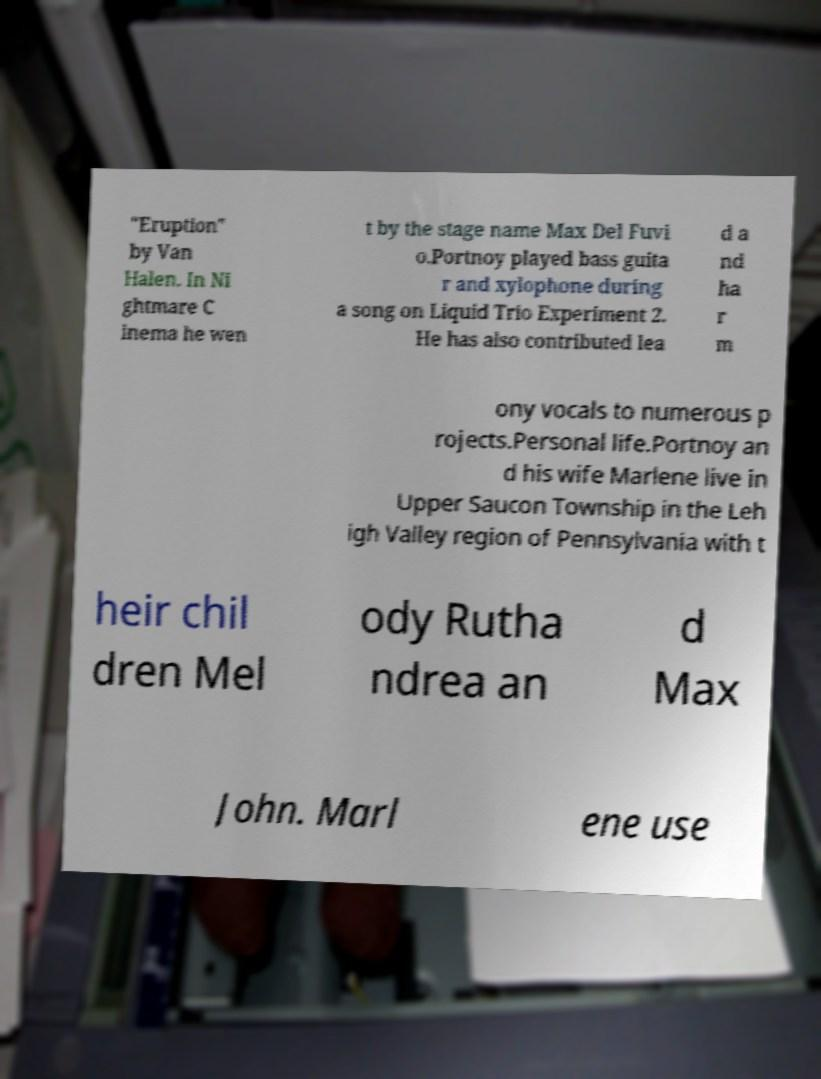For documentation purposes, I need the text within this image transcribed. Could you provide that? "Eruption" by Van Halen. In Ni ghtmare C inema he wen t by the stage name Max Del Fuvi o.Portnoy played bass guita r and xylophone during a song on Liquid Trio Experiment 2. He has also contributed lea d a nd ha r m ony vocals to numerous p rojects.Personal life.Portnoy an d his wife Marlene live in Upper Saucon Township in the Leh igh Valley region of Pennsylvania with t heir chil dren Mel ody Rutha ndrea an d Max John. Marl ene use 